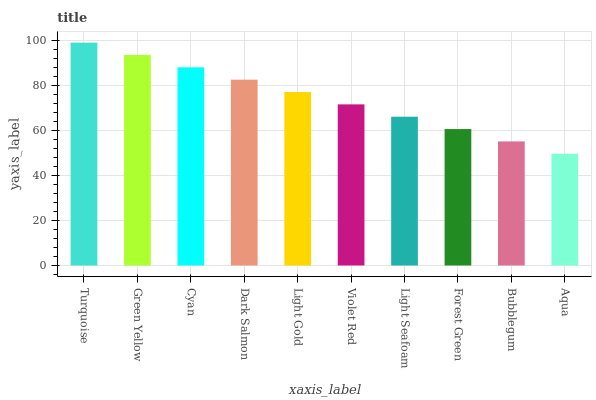Is Aqua the minimum?
Answer yes or no. Yes. Is Turquoise the maximum?
Answer yes or no. Yes. Is Green Yellow the minimum?
Answer yes or no. No. Is Green Yellow the maximum?
Answer yes or no. No. Is Turquoise greater than Green Yellow?
Answer yes or no. Yes. Is Green Yellow less than Turquoise?
Answer yes or no. Yes. Is Green Yellow greater than Turquoise?
Answer yes or no. No. Is Turquoise less than Green Yellow?
Answer yes or no. No. Is Light Gold the high median?
Answer yes or no. Yes. Is Violet Red the low median?
Answer yes or no. Yes. Is Forest Green the high median?
Answer yes or no. No. Is Cyan the low median?
Answer yes or no. No. 